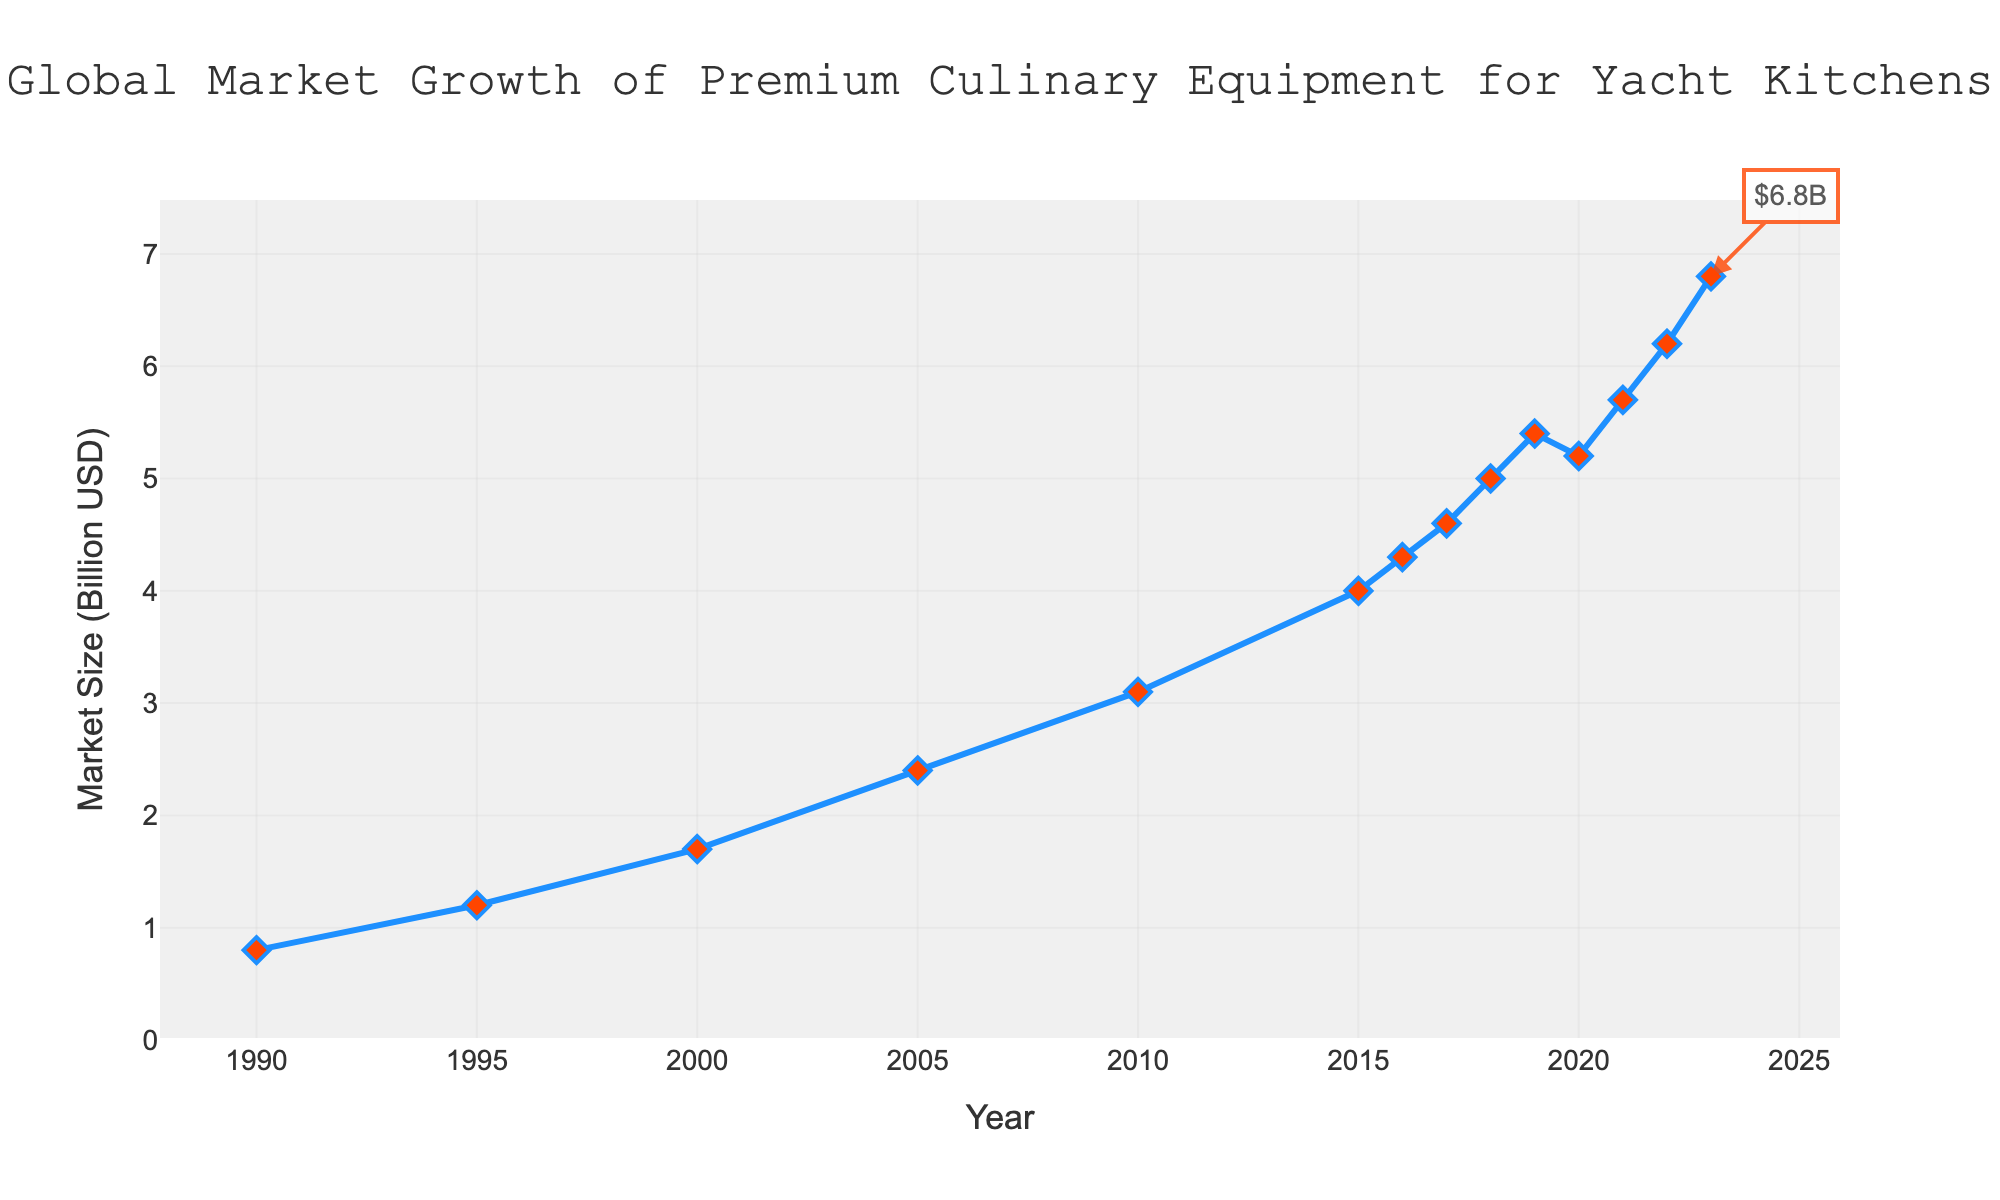What is the general trend of the global market size of premium culinary equipment for yacht kitchens from 1990 to 2023? The line chart shows an overall upward trend in the market size from 1990 (0.8 billion USD) to 2023 (6.8 billion USD). The marker positions and the line connecting them generally increase over time.
Answer: Increasing What was the market size in 2010, and how does it compare to the market size in 2023? In 2010, the market size was 3.1 billion USD, and in 2023, it is 6.8 billion USD. Comparing these values, the market size more than doubled from 2010 to 2023.
Answer: More than doubled Between which consecutive years did the market size experience the most significant increase? By examining the line chart and the steepness of the line segments, the most significant increase occurs between 2022 and 2023 where the market size increased from 6.2 billion USD to 6.8 billion USD.
Answer: 2022 to 2023 What is the total increase in market size from 1990 to 2023? The initial market size in 1990 was 0.8 billion USD and the final size in 2023 is 6.8 billion USD. The total increase is calculated by subtracting the initial value from the final value: 6.8 - 0.8 = 6.0 billion USD.
Answer: 6.0 billion USD How many years did it take for the market size to double from its value in 1990? The market size in 1990 was 0.8 billion USD. Doubling this value gives 1.6 billion USD. The market size reached 1.7 billion USD in 2000, which took 10 years.
Answer: 10 years Identify a year where the market size decreased compared to the previous year and state the value of decrease. From the chart, between 2019 and 2020, the market size decreased from 5.4 billion USD to 5.2 billion USD. The decrease in value is 5.4 - 5.2 = 0.2 billion USD.
Answer: 2020, 0.2 billion USD What is the average annual growth rate of the market size from 1990 to 2023? Calculate the total increase over 33 years (2023 - 1990), which is 6.0 billion USD. The average annual growth rate is then 6.0 / 33 ≈ 0.182 billion USD per year.
Answer: 0.182 billion USD per year During which five-year period was the growth rate of the market size the highest? Examining the chart, the highest five-year growth rate appears between 2000 and 2005, where the market size rose from 1.7 billion USD to 2.4 billion USD. The growth rate is (2.4 - 1.7) / 5 = 0.14 billion USD per year.
Answer: 2000 to 2005 What visual elements are used in the chart to represent the data points and their importance? The chart uses a blue line to connect the data points and red diamond markers to highlight specific data points for each year. These elements help to easily identify changes and trends in the market size over time.
Answer: Blue line and red diamond markers 